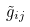Convert formula to latex. <formula><loc_0><loc_0><loc_500><loc_500>\tilde { g } _ { i j }</formula> 